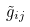Convert formula to latex. <formula><loc_0><loc_0><loc_500><loc_500>\tilde { g } _ { i j }</formula> 